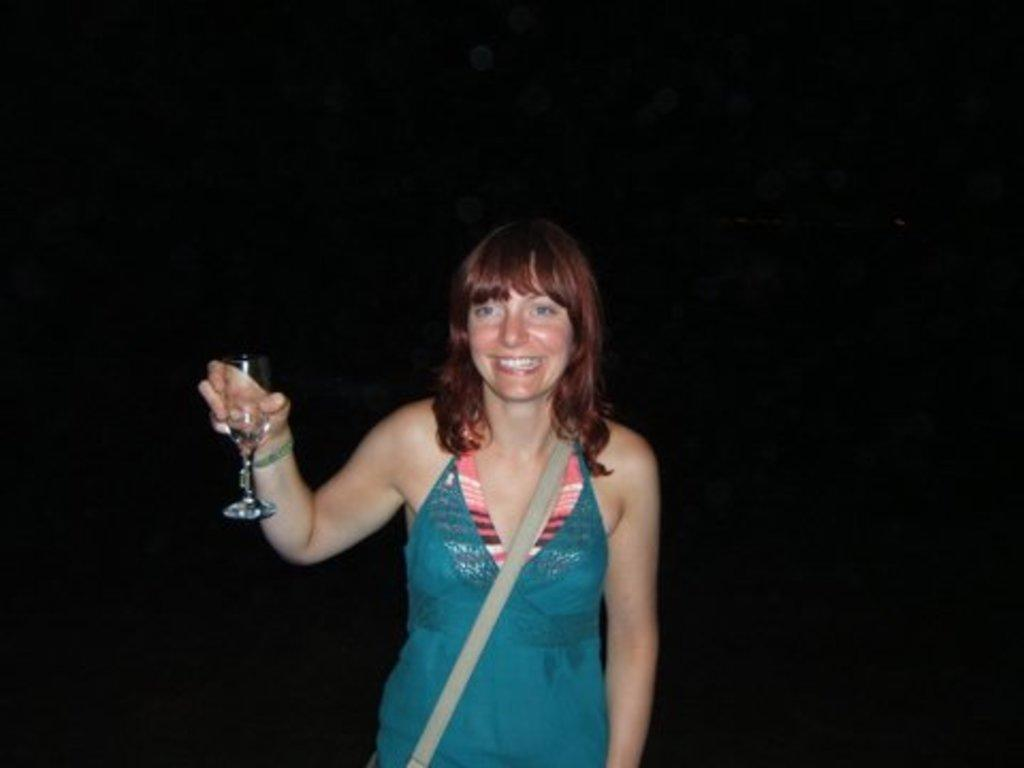Who is the main subject in the image? There is a woman in the image. What is the woman doing in the image? The woman is standing in the image. What object is the woman holding in the image? The woman is holding a glass in the image. How many cars can be seen in the image? There are no cars present in the image; it features a woman standing and holding a glass. 